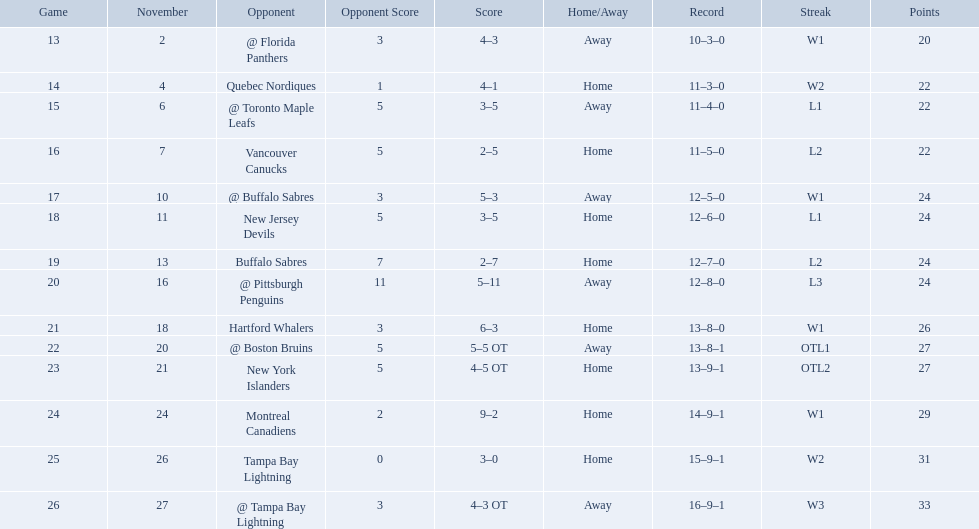Who did the philadelphia flyers play in game 17? @ Buffalo Sabres. What was the score of the november 10th game against the buffalo sabres? 5–3. Which team in the atlantic division had less points than the philadelphia flyers? Tampa Bay Lightning. What are the teams in the atlantic division? Quebec Nordiques, Vancouver Canucks, New Jersey Devils, Buffalo Sabres, Hartford Whalers, New York Islanders, Montreal Canadiens, Tampa Bay Lightning. Which of those scored fewer points than the philadelphia flyers? Tampa Bay Lightning. What were the scores of the 1993-94 philadelphia flyers season? 4–3, 4–1, 3–5, 2–5, 5–3, 3–5, 2–7, 5–11, 6–3, 5–5 OT, 4–5 OT, 9–2, 3–0, 4–3 OT. Which of these teams had the score 4-5 ot? New York Islanders. 